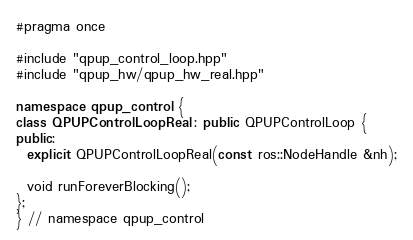<code> <loc_0><loc_0><loc_500><loc_500><_C++_>#pragma once

#include "qpup_control_loop.hpp"
#include "qpup_hw/qpup_hw_real.hpp"

namespace qpup_control {
class QPUPControlLoopReal : public QPUPControlLoop {
public:
  explicit QPUPControlLoopReal(const ros::NodeHandle &nh);

  void runForeverBlocking();
};
} // namespace qpup_control
</code> 